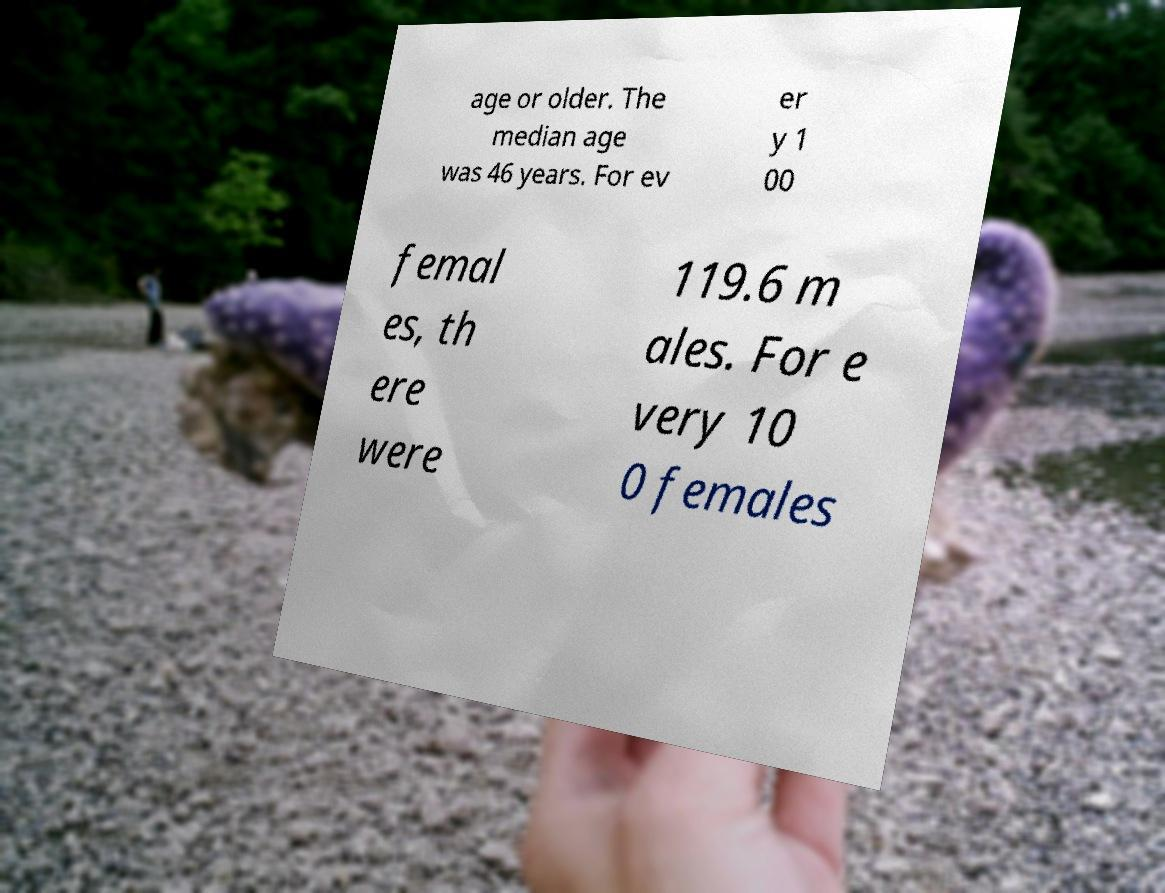Could you assist in decoding the text presented in this image and type it out clearly? age or older. The median age was 46 years. For ev er y 1 00 femal es, th ere were 119.6 m ales. For e very 10 0 females 